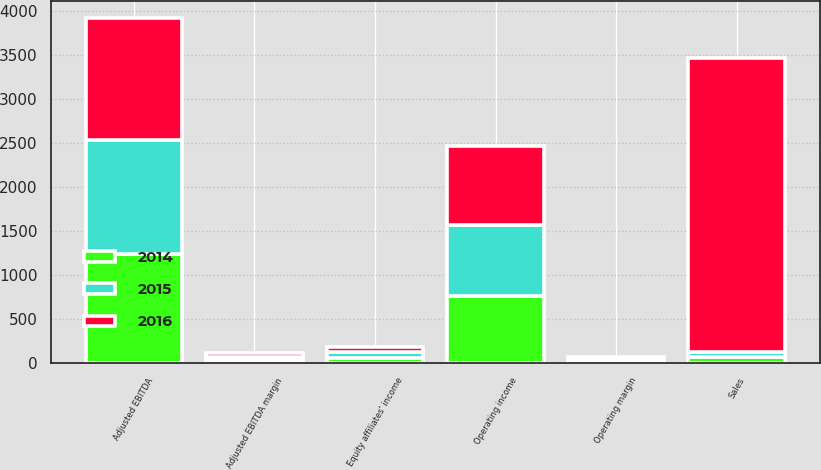Convert chart to OTSL. <chart><loc_0><loc_0><loc_500><loc_500><stacked_bar_chart><ecel><fcel>Sales<fcel>Operating income<fcel>Operating margin<fcel>Equity affiliates' income<fcel>Adjusted EBITDA<fcel>Adjusted EBITDA margin<nl><fcel>2016<fcel>3343.6<fcel>895.2<fcel>26.8<fcel>52.7<fcel>1390.4<fcel>41.6<nl><fcel>2015<fcel>62.75<fcel>808.4<fcel>21.9<fcel>64.6<fcel>1289.9<fcel>34.9<nl><fcel>2014<fcel>62.75<fcel>762.6<fcel>18.7<fcel>60.9<fcel>1237.9<fcel>30.4<nl></chart> 